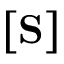Convert formula to latex. <formula><loc_0><loc_0><loc_500><loc_500>\left [ S \right ]</formula> 